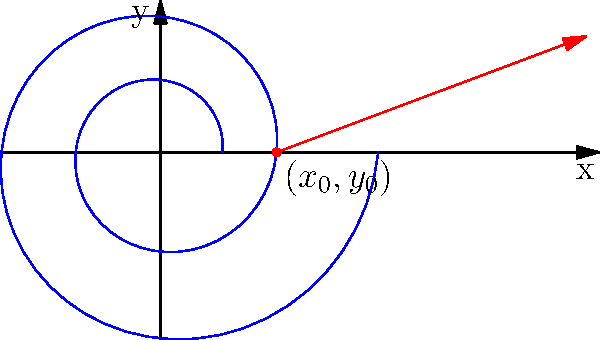A spiral galaxy's path in a 2D coordinate system is described by the parametric equations:
$$x = 0.2e^{0.1t}\cos(t)$$
$$y = 0.2e^{0.1t}\sin(t)$$
At the point $(x_0,y_0)$ corresponding to $t = 2\pi$, find the slope of the tangent line to the galaxy's path. Round your answer to three decimal places. To find the slope of the tangent line, we need to use the formula for the derivative of a parametric curve:

$$\frac{dy}{dx} = \frac{\frac{dy}{dt}}{\frac{dx}{dt}}$$

Step 1: Find $\frac{dx}{dt}$
$$\frac{dx}{dt} = 0.2e^{0.1t}(-0.1\sin(t)) + 0.2e^{0.1t}(0.1\cos(t))$$
$$\frac{dx}{dt} = 0.02e^{0.1t}(\cos(t) - \sin(t))$$

Step 2: Find $\frac{dy}{dt}$
$$\frac{dy}{dt} = 0.2e^{0.1t}(0.1\sin(t)) + 0.2e^{0.1t}(0.1\cos(t))$$
$$\frac{dy}{dt} = 0.02e^{0.1t}(\sin(t) + \cos(t))$$

Step 3: Calculate $\frac{dy}{dx}$ at $t = 2\pi$
$$\frac{dy}{dx} = \frac{0.02e^{0.1t}(\sin(t) + \cos(t))}{0.02e^{0.1t}(\cos(t) - \sin(t))}$$

$$\frac{dy}{dx} = \frac{\sin(t) + \cos(t)}{\cos(t) - \sin(t)}$$

At $t = 2\pi$:
$$\frac{dy}{dx} = \frac{\sin(2\pi) + \cos(2\pi)}{\cos(2\pi) - \sin(2\pi)} = \frac{0 + 1}{1 - 0} = 1$$

Therefore, the slope of the tangent line at $t = 2\pi$ is 1.
Answer: 1.000 